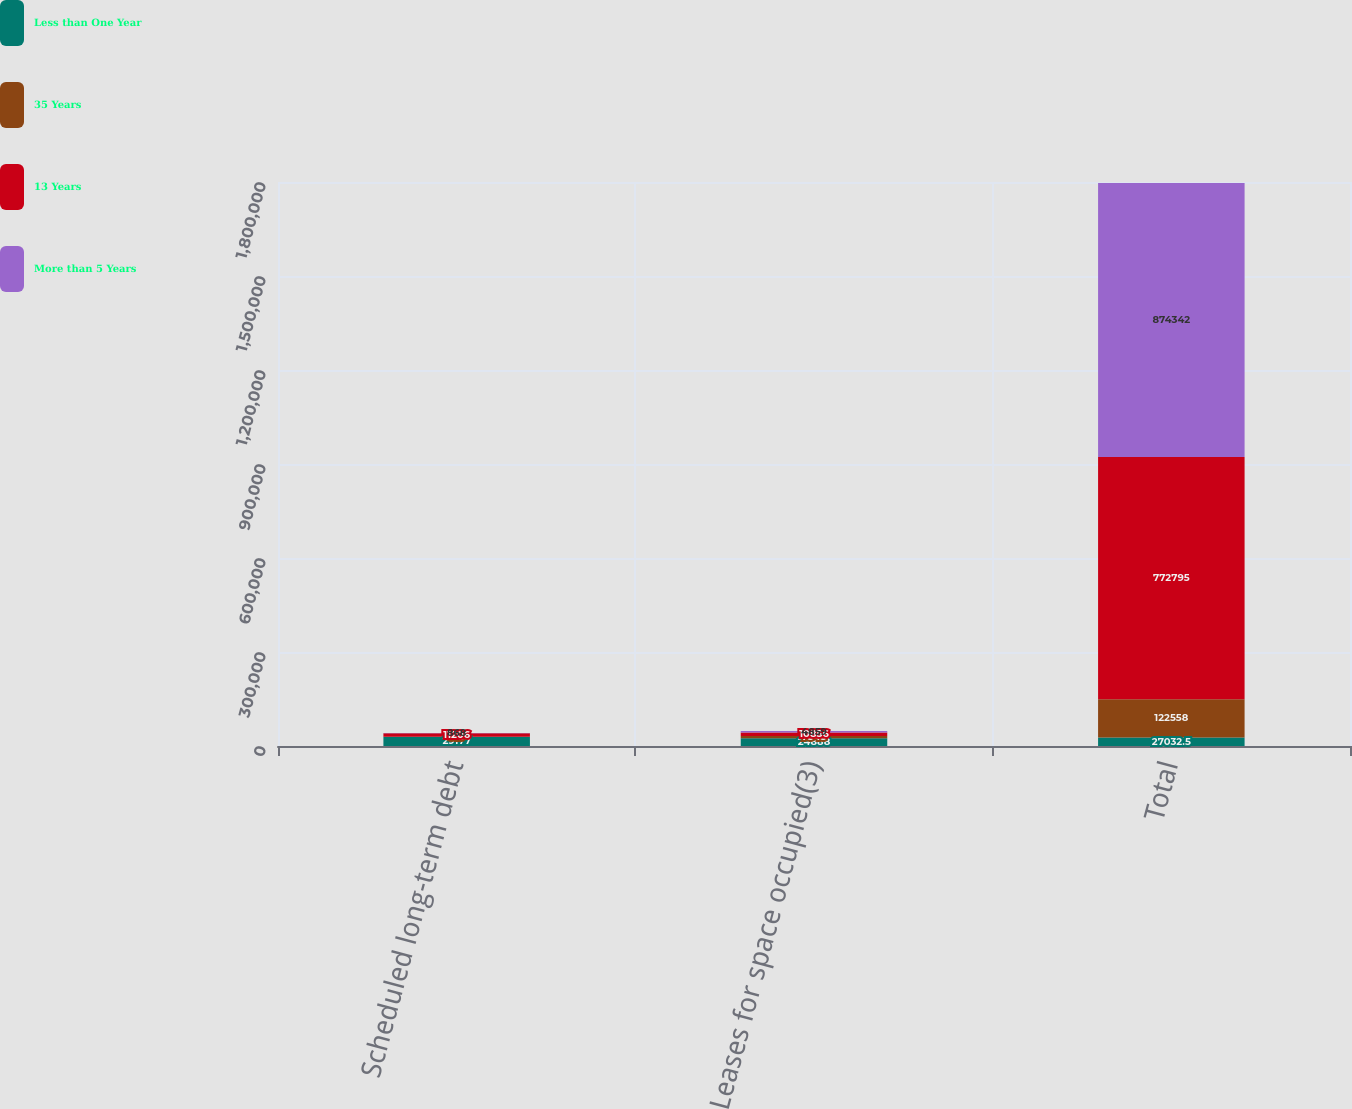<chart> <loc_0><loc_0><loc_500><loc_500><stacked_bar_chart><ecel><fcel>Scheduled long-term debt<fcel>Leases for space occupied(3)<fcel>Total<nl><fcel>Less than One Year<fcel>29177<fcel>24888<fcel>27032.5<nl><fcel>35 Years<fcel>519<fcel>7345<fcel>122558<nl><fcel>13 Years<fcel>11206<fcel>10856<fcel>772795<nl><fcel>More than 5 Years<fcel>868<fcel>4859<fcel>874342<nl></chart> 